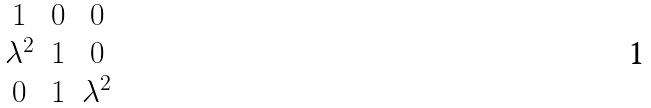<formula> <loc_0><loc_0><loc_500><loc_500>\begin{matrix} 1 & 0 & 0 \\ \lambda ^ { 2 } & 1 & 0 \\ 0 & 1 & \lambda ^ { 2 } \\ \end{matrix}</formula> 